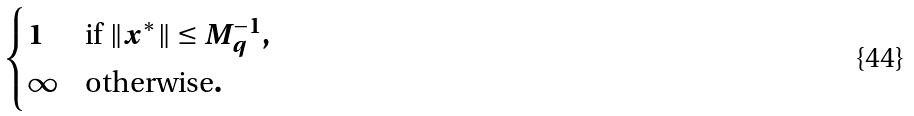<formula> <loc_0><loc_0><loc_500><loc_500>\begin{cases} 1 & \text {if } \| x ^ { * } \| \leq M _ { q } ^ { - 1 } , \\ \infty & \text {otherwise} . \end{cases}</formula> 